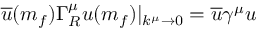Convert formula to latex. <formula><loc_0><loc_0><loc_500><loc_500>\overline { u } ( m _ { f } ) \Gamma _ { R } ^ { \mu } u ( m _ { f } ) | _ { k ^ { \mu } \rightarrow 0 } = \overline { u } \gamma ^ { \mu } u</formula> 